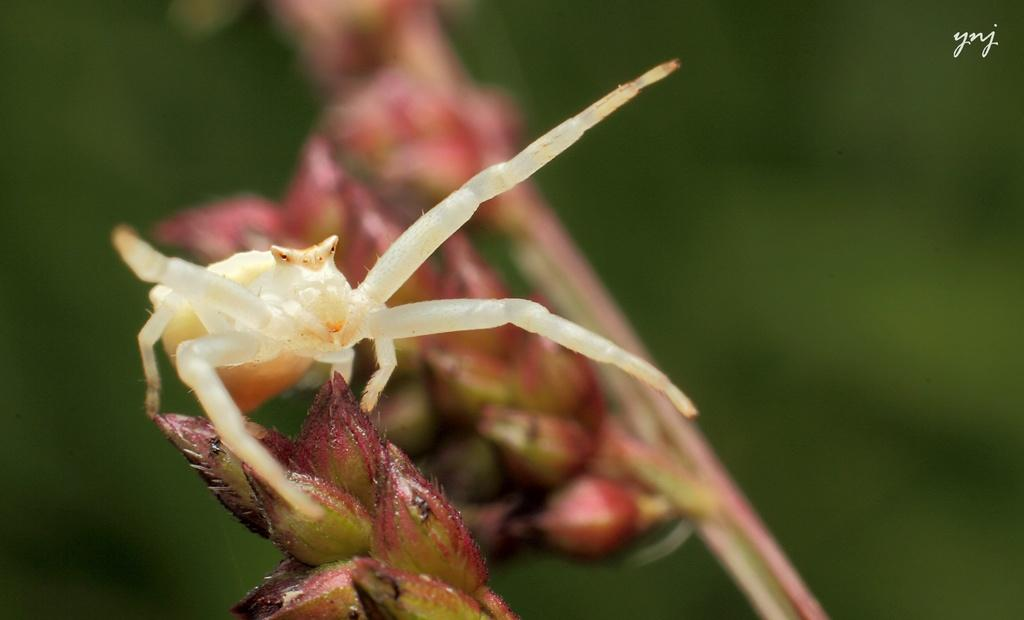What is the main subject of the image? The main subject of the image is a spider. Where is the spider located in the image? The spider is on the stem of a plant. What type of history is the spider writing in the image? There is no indication in the image that the spider is writing history or any other type of content. 